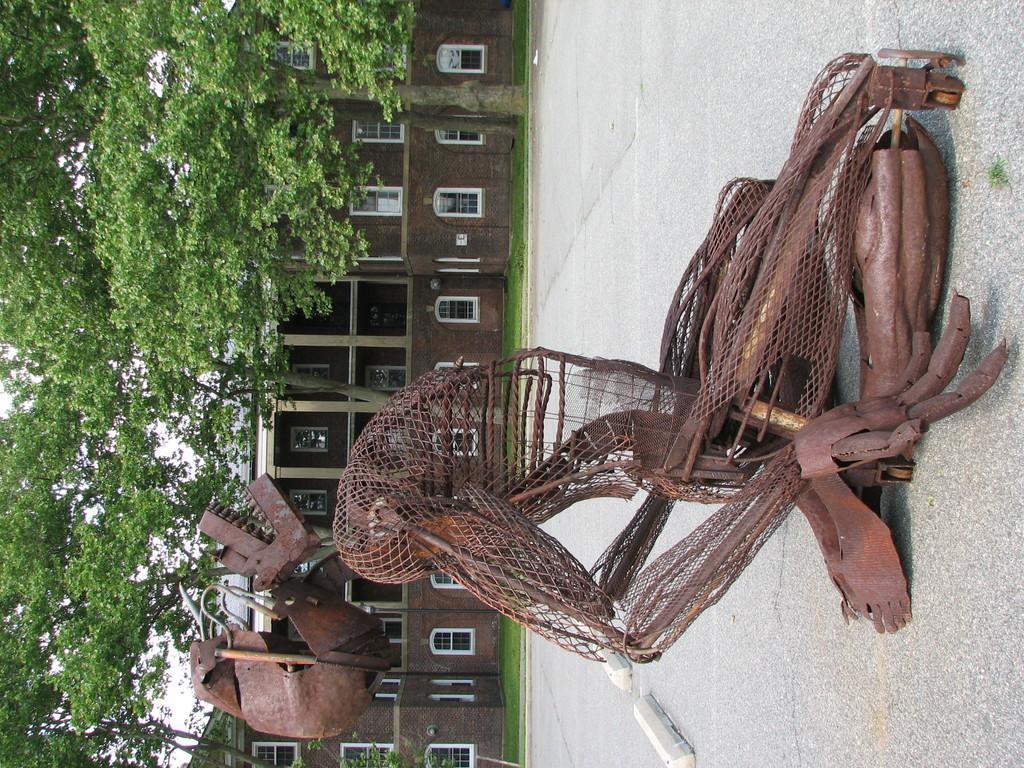Can you describe this image briefly? In this picture I can see metal objects on the surface. I can see the buildings. I can see trees. I can see green grass. 